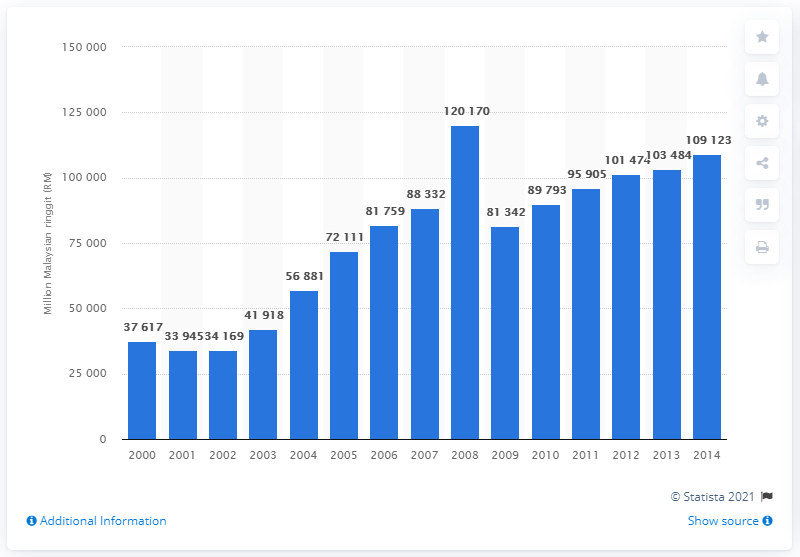Mention a couple of crucial points in this snapshot. In 2013, the gross domestic product generated from mining and quarrying in Malaysia was 103,484. 